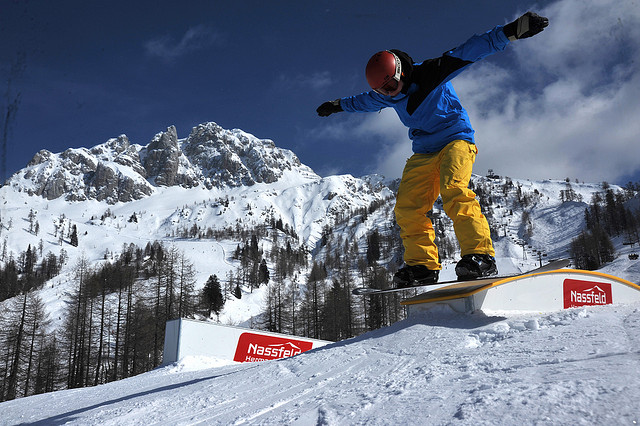How would you describe the general ambiance of the scene? The ambiance of the scene is a harmonious blend of exhilaration and tranquility. The sharp contrast of the snowboarder’s bright attire against the pristine snow creates a dynamic feel, while the vast, serene mountains in the background evoke a sense of peace and timelessness. The clear blue sky and bright sunshine add to the invigorating atmosphere, making this a perfect moment where nature and human endeavor unite seamlessly. 